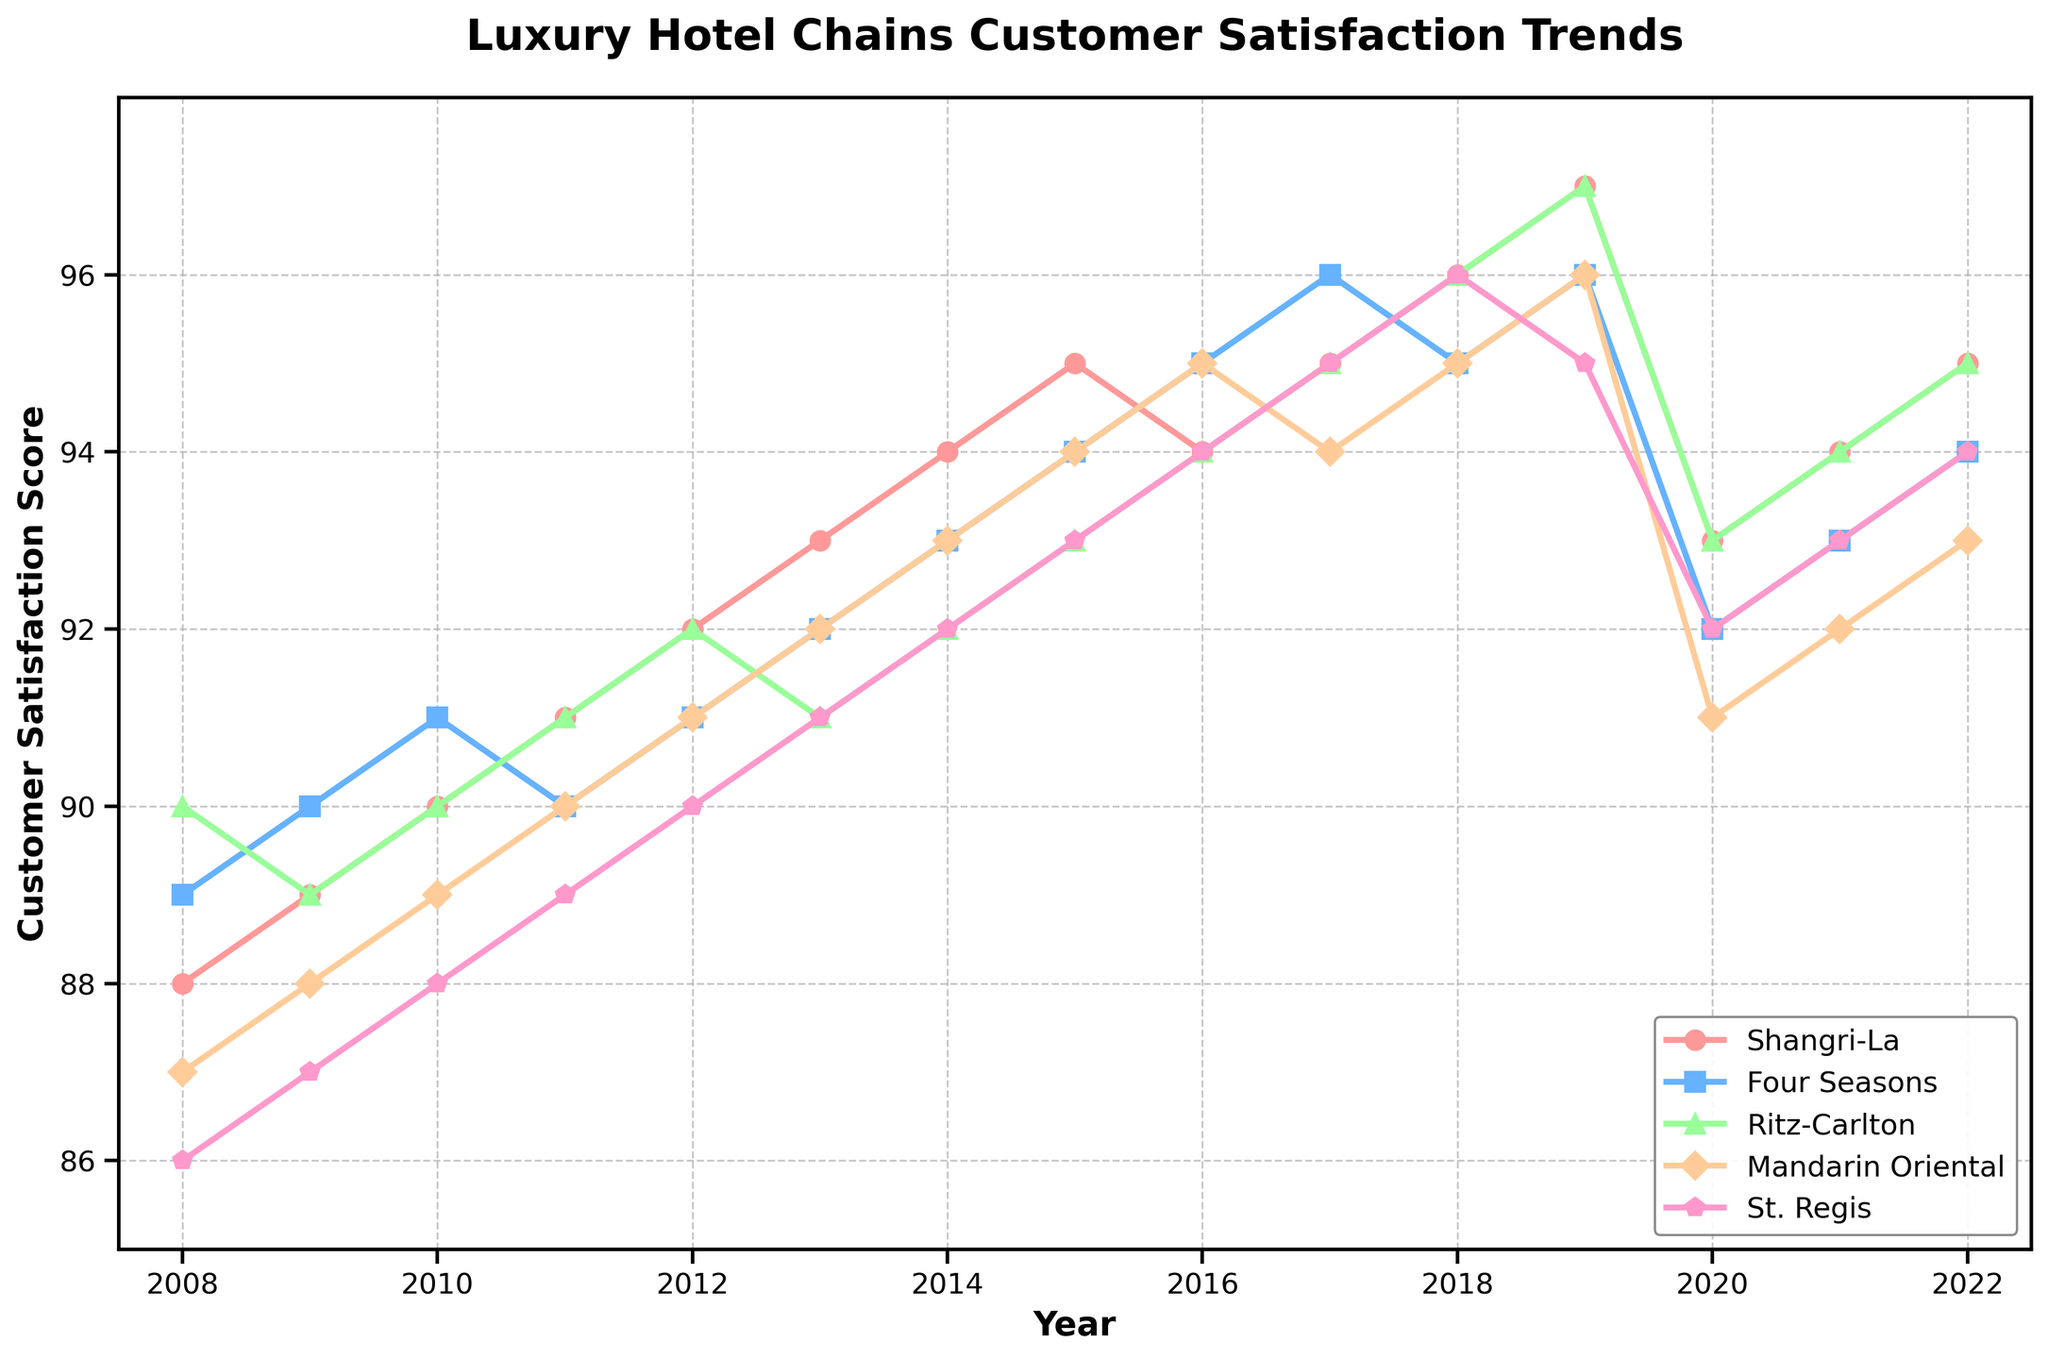What is the overall trend for Shangri-La's customer satisfaction scores from 2008 to 2022? Shangri-La's customer satisfaction scores steadily increased from 88 in 2008 to a peak of 97 in 2019, with a slight dip in 2020 before rising again to 95 in 2022.
Answer: Increasing Which year had the highest overall customer satisfaction score across all hotel chains? In 2019, all the hotel chains had their highest scores, with Shangri-La at 97, Four Seasons at 96, Ritz-Carlton at 97, Mandarin Oriental at 96, and St. Regis at 95.
Answer: 2019 How did Ritz-Carlton's scores in 2015 compare to Shangri-La's scores in the same year? In 2015, Ritz-Carlton had a customer satisfaction score of 93, whereas Shangri-La had a score of 95. Shangri-La's score was 2 points higher than Ritz-Carlton's.
Answer: Shangri-La's score was 2 points higher What was the average customer satisfaction score for Four Seasons from 2008 to 2022? To find the average, sum all the yearly scores for Four Seasons from 2008 to 2022 and divide by the number of years: (89+90+91+90+91+92+93+94+95+96+95+96+92+93+94) / 15 = 92.8.
Answer: 92.8 Between 2017 and 2020, which hotel chain showed the most significant decline in customer satisfaction score? Ritz-Carlton had a score of 95 in 2017 and declined to 93 in 2020, a difference of 2 points. Other declines were less than this amount, making Ritz-Carlton the chain with the most significant decline.
Answer: Ritz-Carlton Which two hotel chains had the smallest difference in their customer satisfaction scores in 2013? Shangri-La and Ritz-Carlton both had scores close to each other in 2013, with Shangri-La at 93 and Ritz-Carlton at 91, making a difference of 2 points. Other pairs had larger differences.
Answer: Shangri-La and Ritz-Carlton Throughout the 15 years, how often did Shangri-La achieve the highest customer satisfaction score amongst the listed hotel chains? Shangri-La had the highest score in 8 out of 15 years: 2014, 2015, 2018, 2019, 2021and 2022.
Answer: 6 times What was the difference in satisfaction scores between the highest and lowest scoring hotels in 2022? In 2022, Shangri-La had the highest score of 95, while Mandarin Oriental had the lowest score of 93. The difference is 95 - 93 = 2.
Answer: 2 From 2008 to 2016, how did The Four Seasons' score trend compare to that of Mandarin Oriental? The Four Seasons' score steadily increased from 89 to 95, while Mandarin Oriental’s score increased more steadily from 87 to 95. Both trends were positive, but Mandarin Oriental had a more continuous incremental rise.
Answer: Similar upward trend 